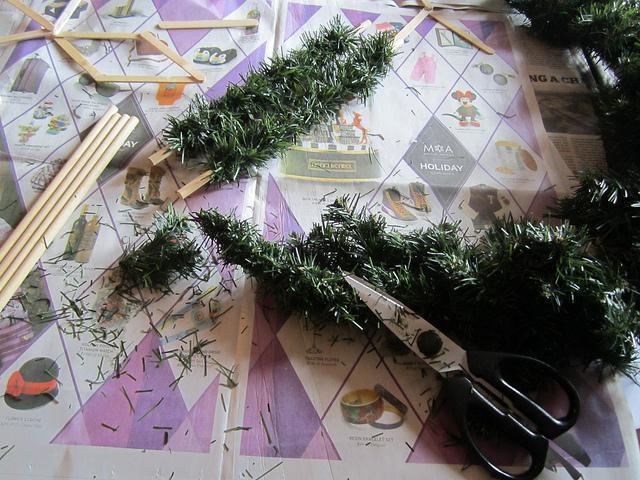How many pairs of scissors are shown in this picture?
Give a very brief answer. 1. 